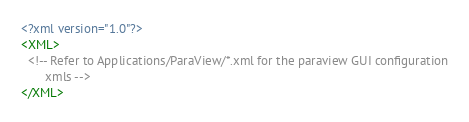<code> <loc_0><loc_0><loc_500><loc_500><_XML_><?xml version="1.0"?>
<XML>
  <!-- Refer to Applications/ParaView/*.xml for the paraview GUI configuration
       xmls -->
</XML>
</code> 